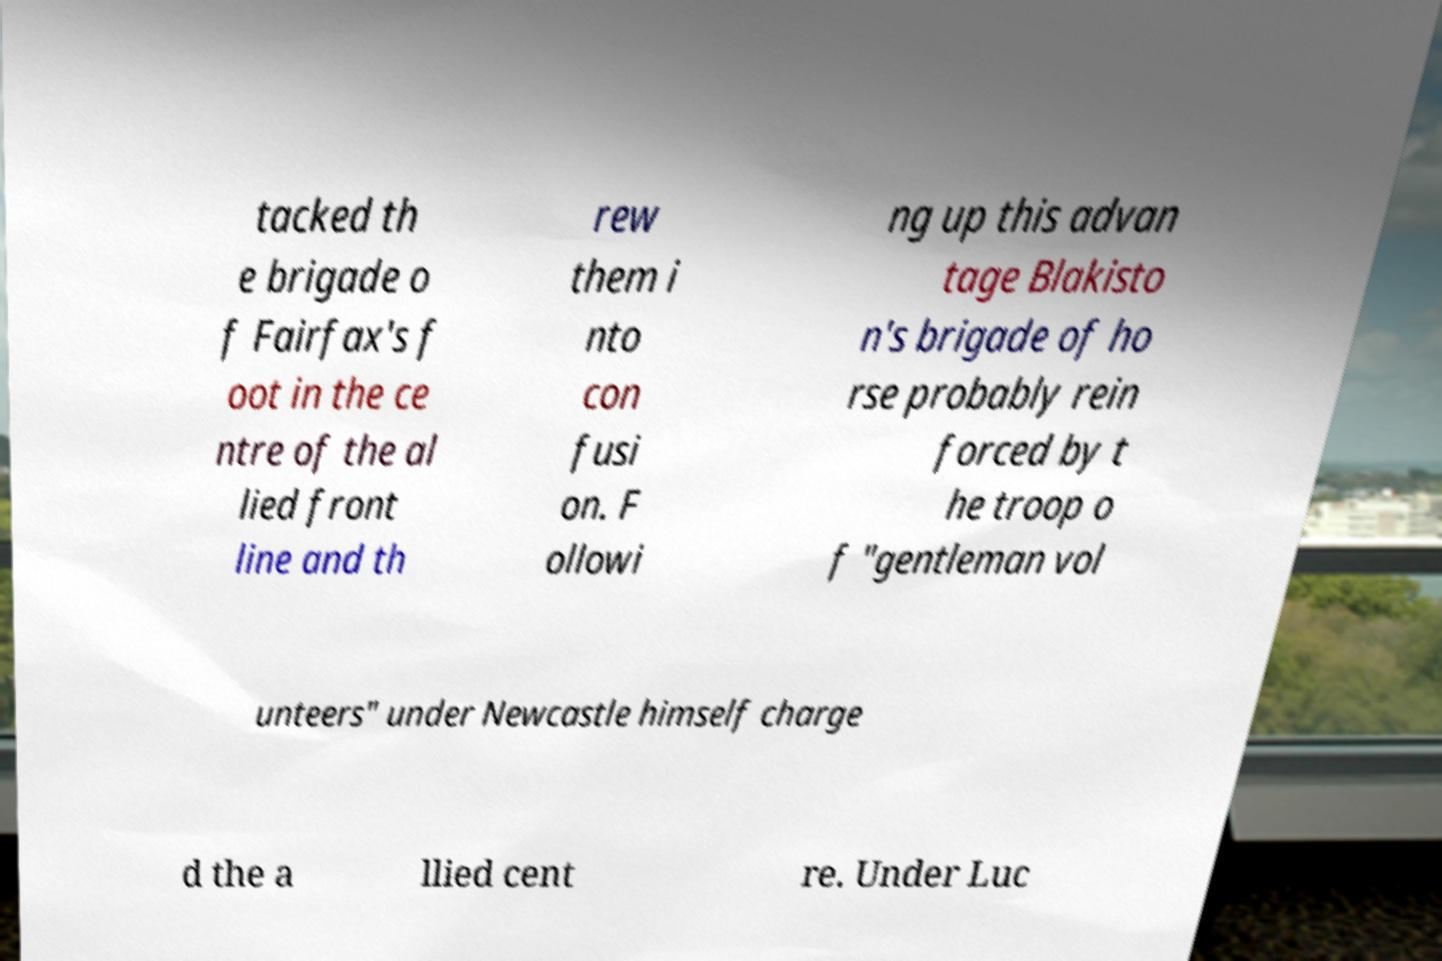What messages or text are displayed in this image? I need them in a readable, typed format. tacked th e brigade o f Fairfax's f oot in the ce ntre of the al lied front line and th rew them i nto con fusi on. F ollowi ng up this advan tage Blakisto n's brigade of ho rse probably rein forced by t he troop o f "gentleman vol unteers" under Newcastle himself charge d the a llied cent re. Under Luc 